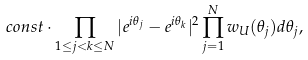<formula> <loc_0><loc_0><loc_500><loc_500>c o n s t \cdot \prod _ { 1 \leq j < k \leq N } | e ^ { i \theta _ { j } } - e ^ { i \theta _ { k } } | ^ { 2 } \prod _ { j = 1 } ^ { N } w _ { U } ( \theta _ { j } ) d \theta _ { j } ,</formula> 